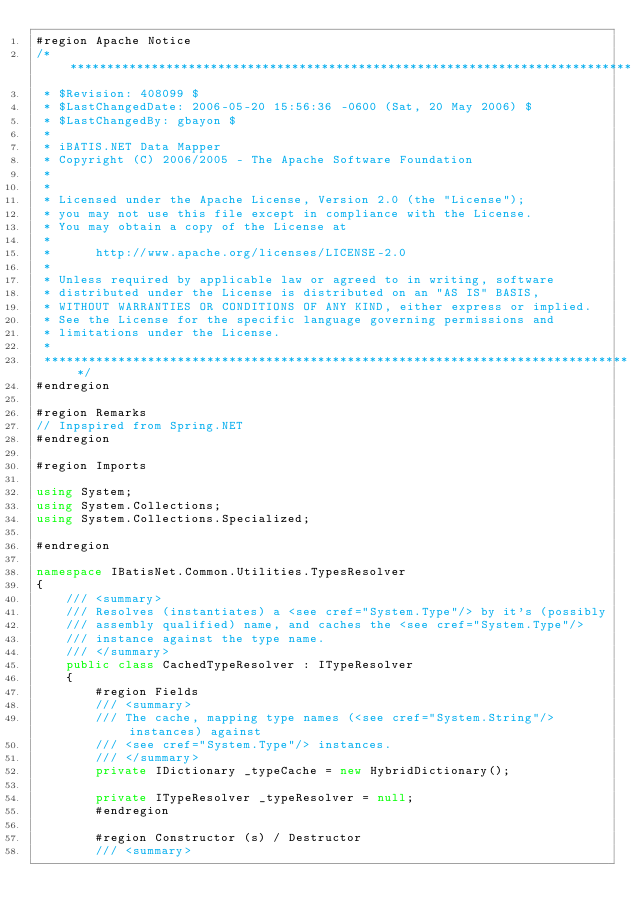<code> <loc_0><loc_0><loc_500><loc_500><_C#_>#region Apache Notice
/*****************************************************************************
 * $Revision: 408099 $
 * $LastChangedDate: 2006-05-20 15:56:36 -0600 (Sat, 20 May 2006) $
 * $LastChangedBy: gbayon $
 * 
 * iBATIS.NET Data Mapper
 * Copyright (C) 2006/2005 - The Apache Software Foundation
 *  
 * 
 * Licensed under the Apache License, Version 2.0 (the "License");
 * you may not use this file except in compliance with the License.
 * You may obtain a copy of the License at
 * 
 *      http://www.apache.org/licenses/LICENSE-2.0
 * 
 * Unless required by applicable law or agreed to in writing, software
 * distributed under the License is distributed on an "AS IS" BASIS,
 * WITHOUT WARRANTIES OR CONDITIONS OF ANY KIND, either express or implied.
 * See the License for the specific language governing permissions and
 * limitations under the License.
 * 
 ********************************************************************************/
#endregion

#region Remarks
// Inpspired from Spring.NET
#endregion

#region Imports

using System;
using System.Collections;
using System.Collections.Specialized;

#endregion

namespace IBatisNet.Common.Utilities.TypesResolver
{
    /// <summary>
    /// Resolves (instantiates) a <see cref="System.Type"/> by it's (possibly
    /// assembly qualified) name, and caches the <see cref="System.Type"/>
    /// instance against the type name.
    /// </summary>
	public class CachedTypeResolver : ITypeResolver
    {
        #region Fields
        /// <summary>
        /// The cache, mapping type names (<see cref="System.String"/> instances) against
        /// <see cref="System.Type"/> instances.
        /// </summary>
        private IDictionary _typeCache = new HybridDictionary();

        private ITypeResolver _typeResolver = null;
        #endregion

        #region Constructor (s) / Destructor
        /// <summary></code> 